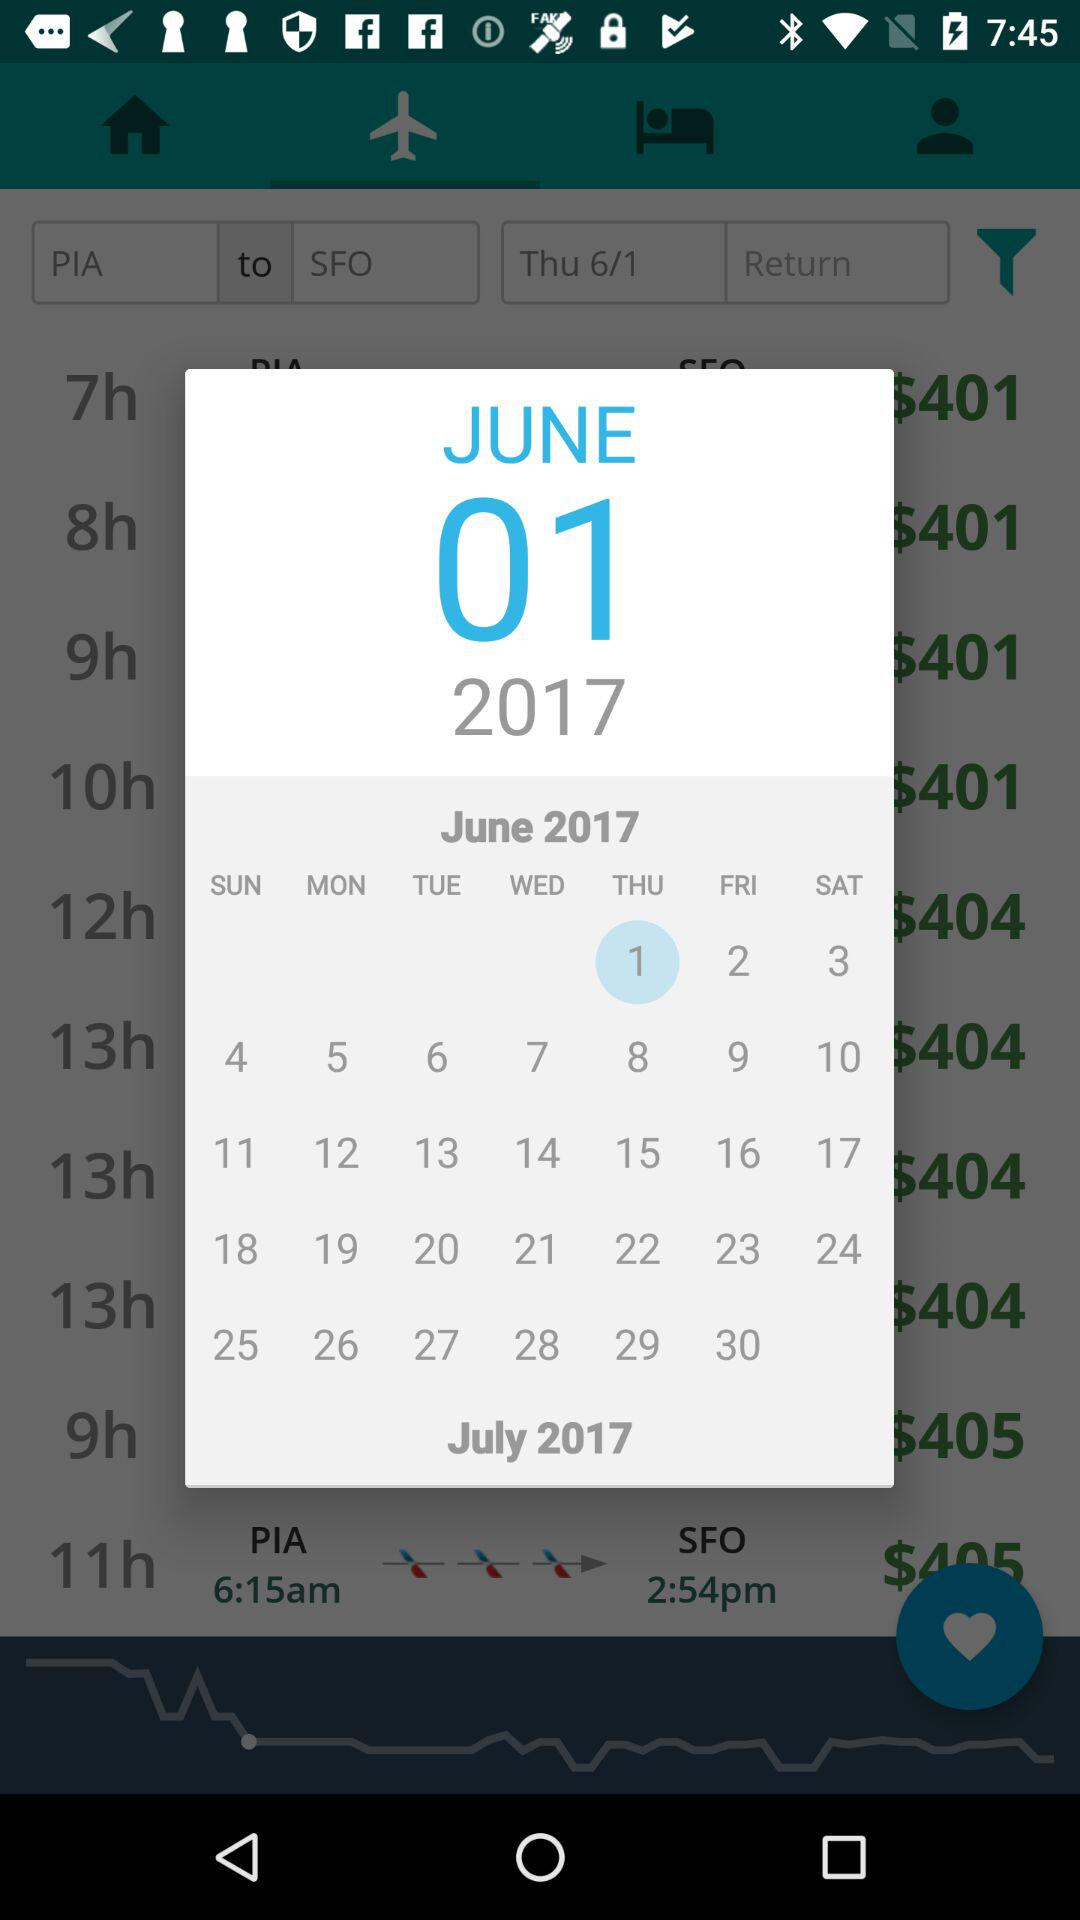What is the date of travel? The date of travel is Thursday, June 1, 2017. 